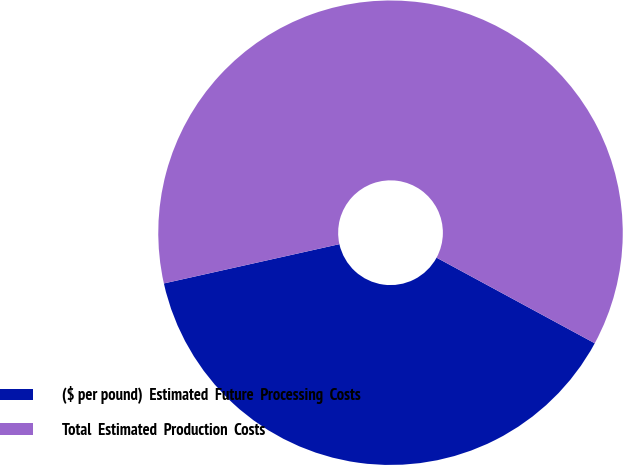Convert chart. <chart><loc_0><loc_0><loc_500><loc_500><pie_chart><fcel>($ per pound)  Estimated  Future  Processing  Costs<fcel>Total  Estimated  Production  Costs<nl><fcel>38.6%<fcel>61.4%<nl></chart> 